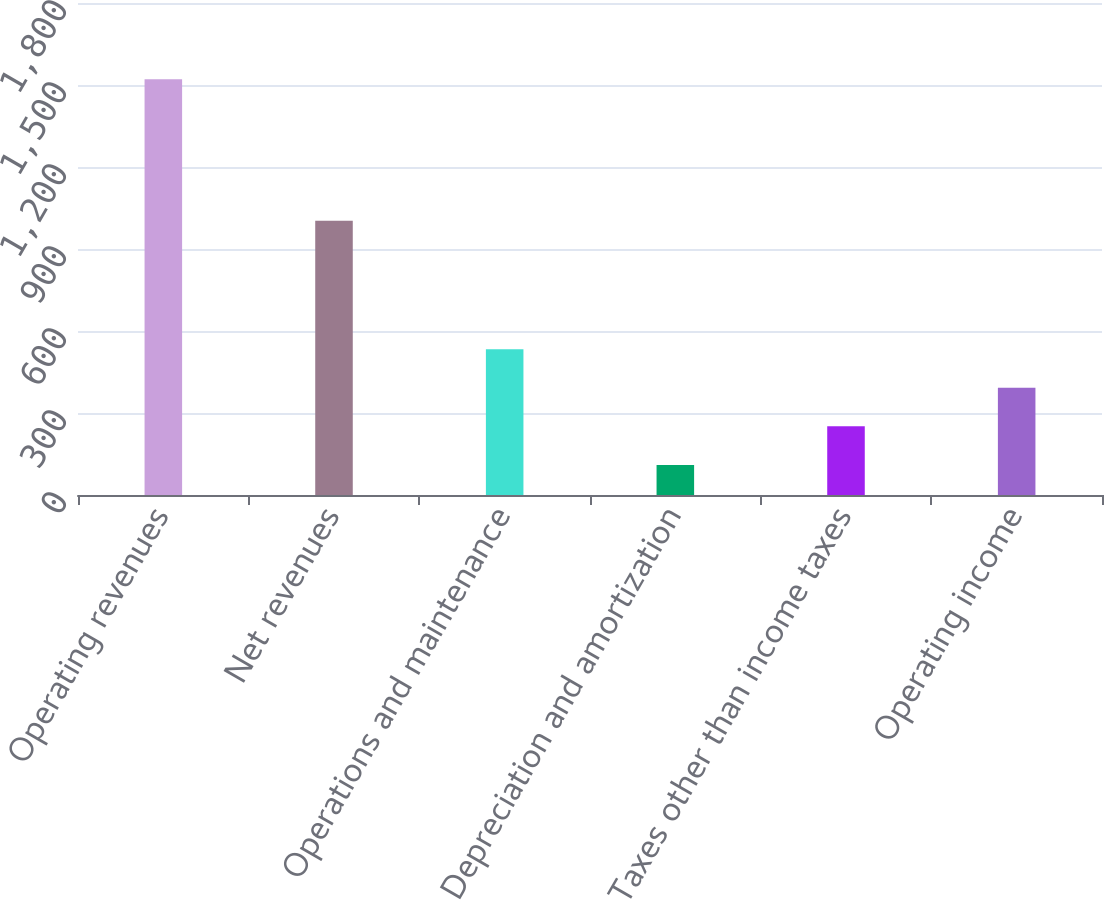Convert chart. <chart><loc_0><loc_0><loc_500><loc_500><bar_chart><fcel>Operating revenues<fcel>Net revenues<fcel>Operations and maintenance<fcel>Depreciation and amortization<fcel>Taxes other than income taxes<fcel>Operating income<nl><fcel>1521<fcel>1003<fcel>533.3<fcel>110<fcel>251.1<fcel>392.2<nl></chart> 